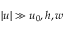<formula> <loc_0><loc_0><loc_500><loc_500>| u | \gg u _ { 0 } , h , w</formula> 